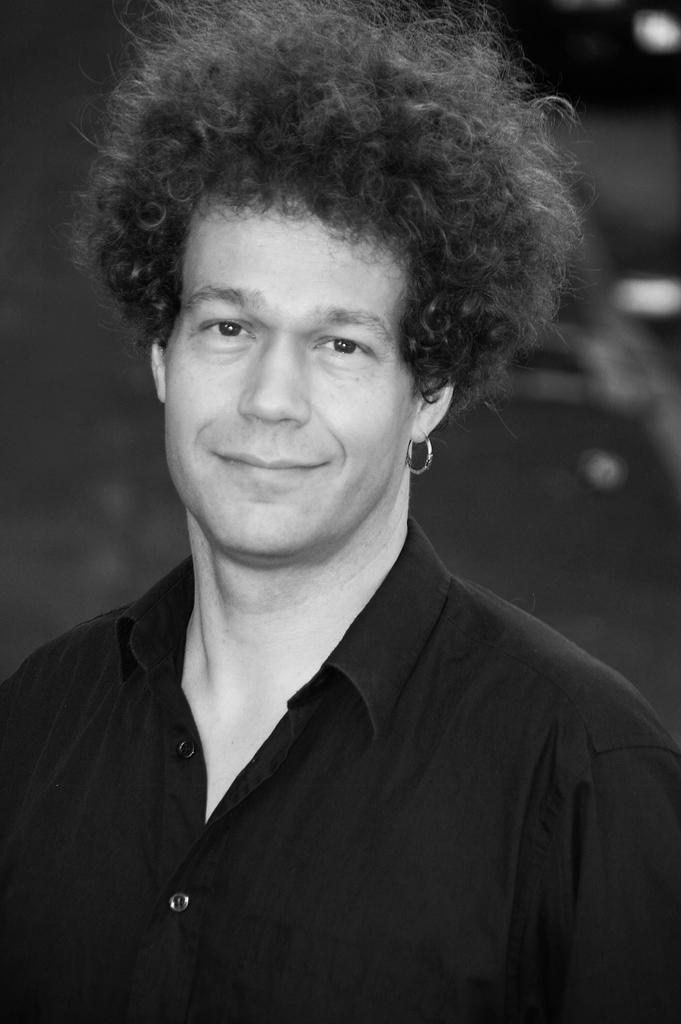What is present in the image? There is a man in the image. How is the man depicted in the image? The man is smiling. Reasoning: Leting: Let's think step by step in order to produce the conversation. We start by identifying the main subject in the image, which is the man. Then, we describe the man's expression, noting that he is smiling. Each question is designed to elicit a specific detail about the image that is known from the provided facts. Absurd Question/Answer: What type of egg is the man holding in the image? There is no egg present in the image; the man is simply smiling. Is the man in the image attacking anyone? There is no indication of an attack or any aggressive behavior in the image; the man is just smiling. What type of copper material is the man using to attack someone in the image? There is no copper material or attack present in the image; the man is simply smiling. 